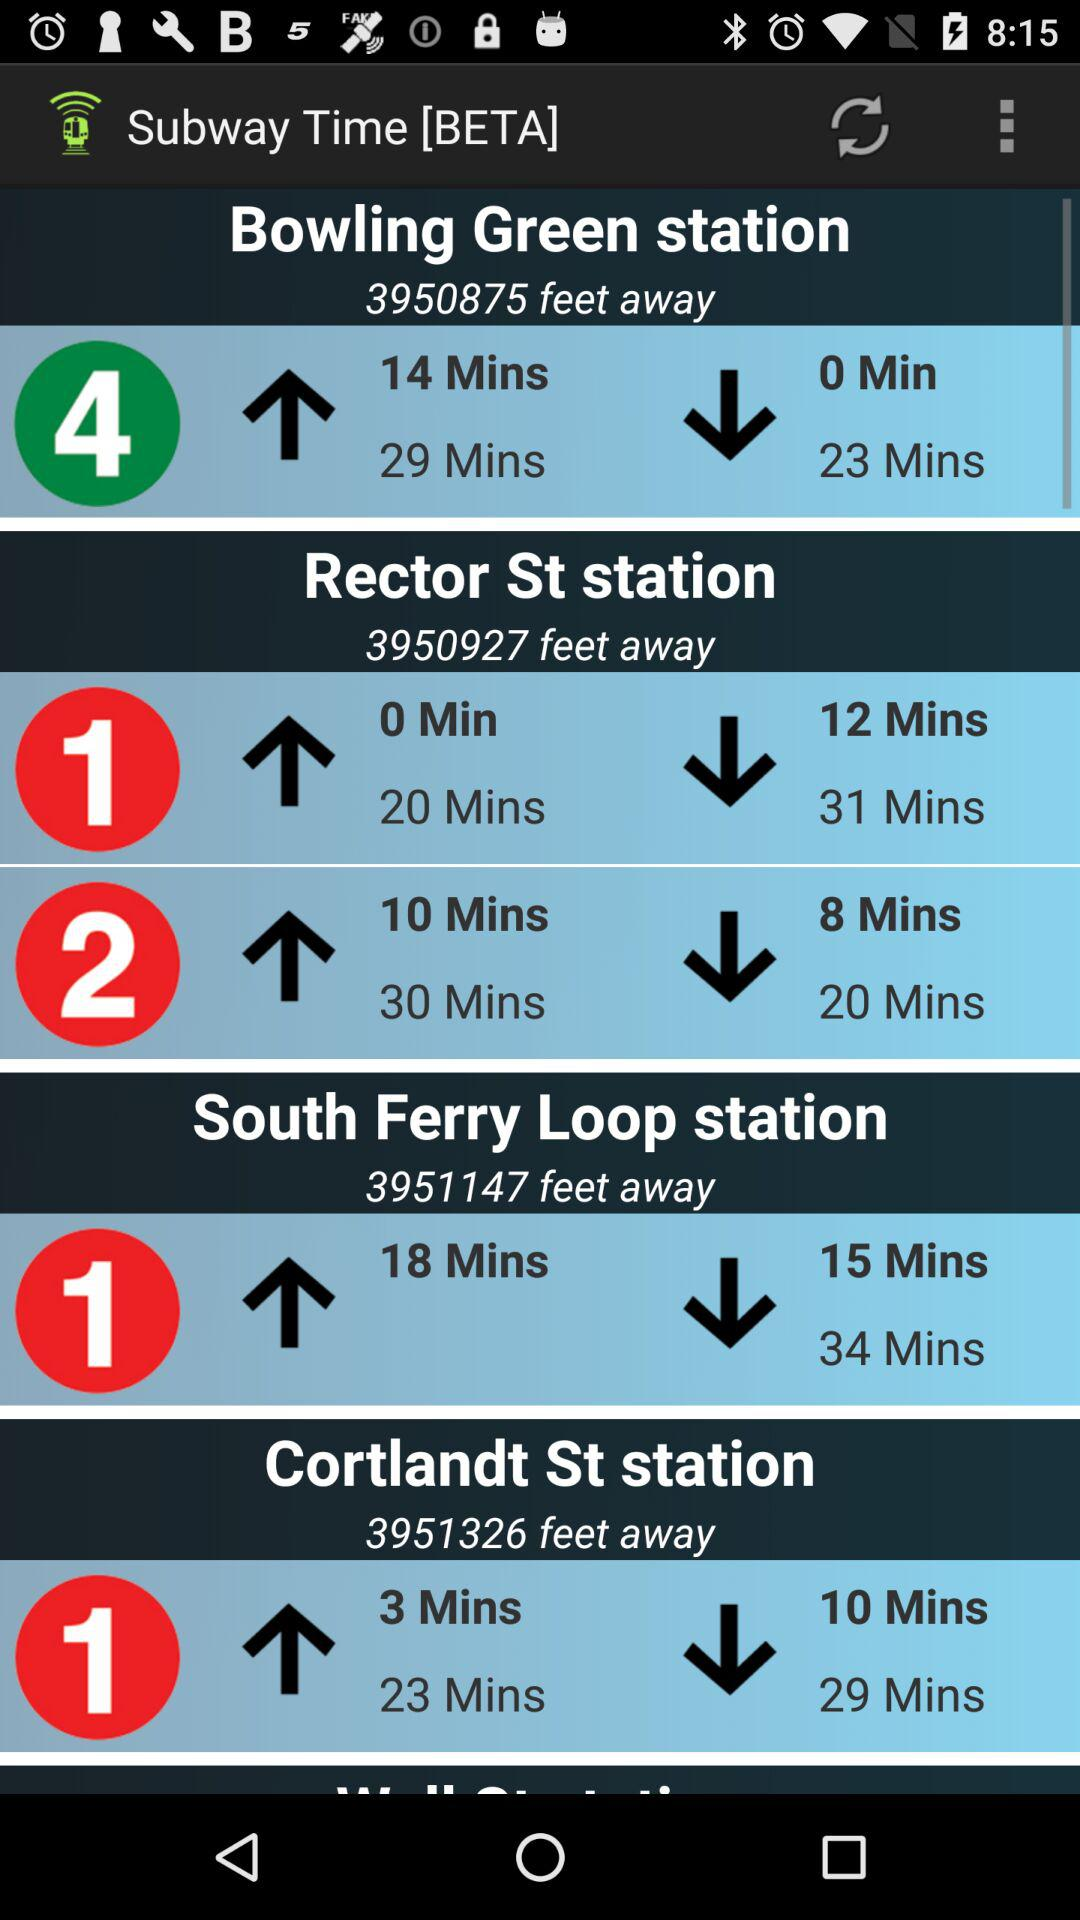How far is the "Bowling Green station"? "Bowling Green station" is 3950875 feet away. 